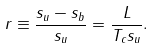Convert formula to latex. <formula><loc_0><loc_0><loc_500><loc_500>r \equiv \frac { s _ { u } - s _ { b } } { s _ { u } } = \frac { L } { T _ { c } s _ { u } } .</formula> 